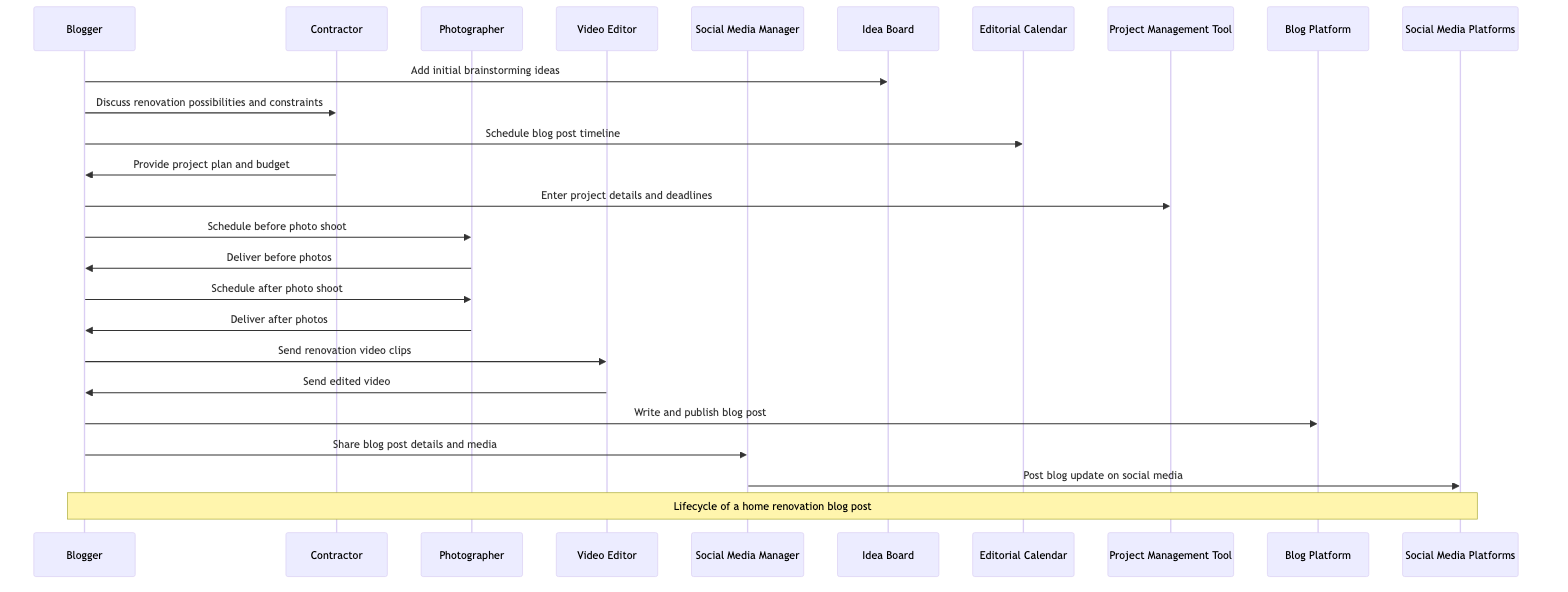What is the first action taken by the Blogger? The first action in the sequence shows the Blogger adding initial brainstorming ideas to the Idea Board. This is the starting point of the blog post lifecycle.
Answer: Add initial brainstorming ideas How many actors are involved in this sequence? By counting the different participants listed in the sequence diagram, we see there are five distinct actors: Blogger, Contractor, Photographer, Video Editor, and Social Media Manager.
Answer: Five What is the last action performed in the sequence? The final action in the sequence is where the Social Media Manager posts the blog update on Social Media Platforms, indicating the completion of the blog post lifecycle.
Answer: Post blog update on social media Which object is used for project detail management? The Project Management Tool is specifically indicated as the object where the Blogger enters project details and deadlines. This tool helps manage the renovation project effectively.
Answer: Project Management Tool What two messages does the Blogger send to the Photographer? The Blogger schedules two photo shoots with the Photographer: one for before the renovation and one for after, as indicated in the sequence. The exact messages would be to "Schedule before photo shoot" and "Schedule after photo shoot."
Answer: Schedule before photo shoot and Schedule after photo shoot How many messages do the Blogger and Contractor exchange in total? The interaction starts with the Blogger discussing renovation possibilities with the Contractor and receives the project plan and budget in return. This totals two messages exchanged between them.
Answer: Two Which actor is responsible for video editing? The Video Editor is the designated actor responsible for processing the video clips sent by the Blogger and delivering the edited version back.
Answer: Video Editor What platform is used to publish the final blog post? The Blog Platform is utilized by the Blogger to write and publish the final blog post once all preparatory work has been completed.
Answer: Blog Platform What does the Social Media Manager do after receiving details from the Blogger? After receiving the details and media from the Blogger, the Social Media Manager posts the updates on various Social Media Platforms to promote the blog content.
Answer: Post blog update on social media 